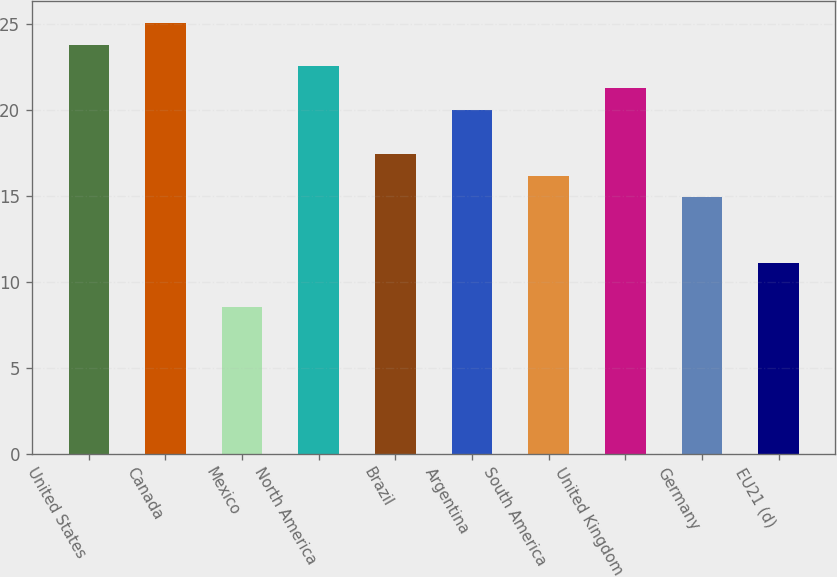Convert chart to OTSL. <chart><loc_0><loc_0><loc_500><loc_500><bar_chart><fcel>United States<fcel>Canada<fcel>Mexico<fcel>North America<fcel>Brazil<fcel>Argentina<fcel>South America<fcel>United Kingdom<fcel>Germany<fcel>EU21 (d)<nl><fcel>23.79<fcel>25.06<fcel>8.55<fcel>22.52<fcel>17.44<fcel>19.98<fcel>16.17<fcel>21.25<fcel>14.9<fcel>11.09<nl></chart> 